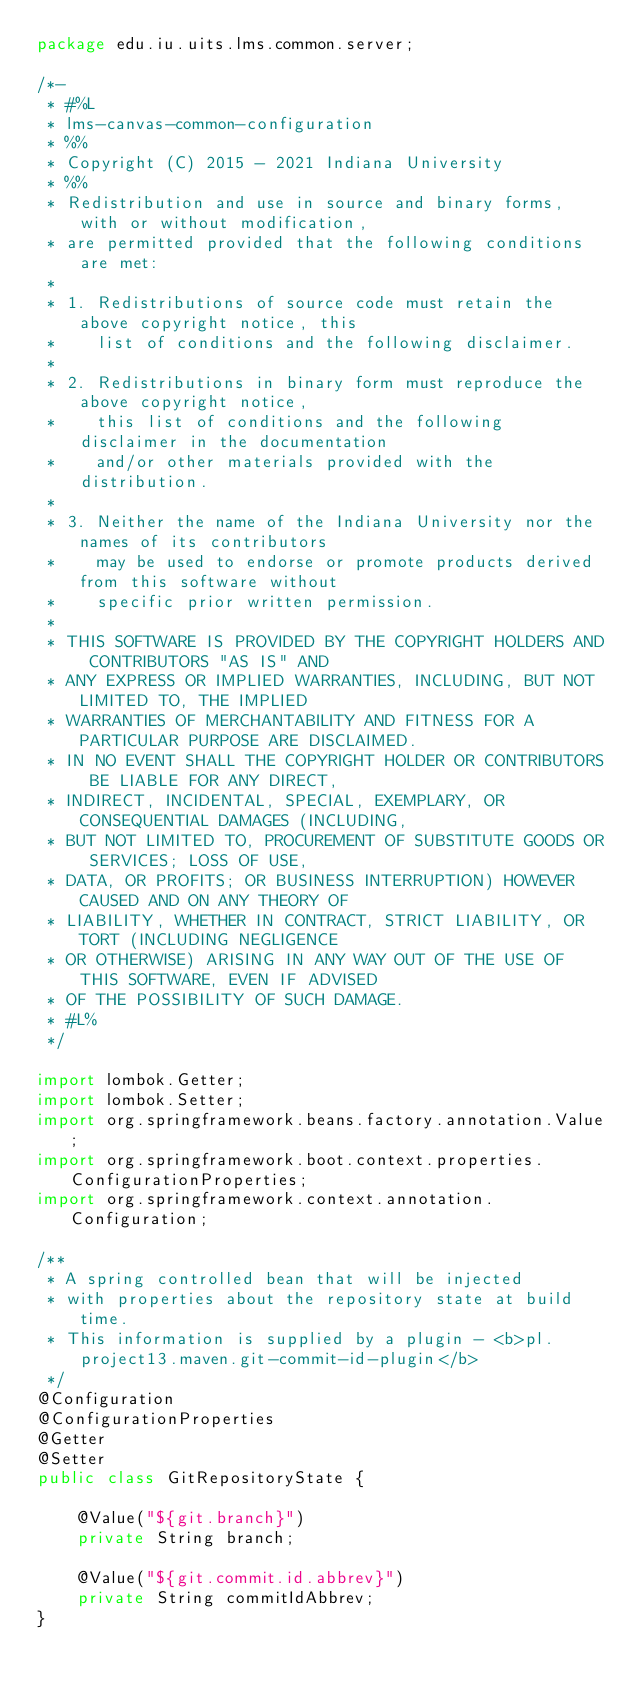Convert code to text. <code><loc_0><loc_0><loc_500><loc_500><_Java_>package edu.iu.uits.lms.common.server;

/*-
 * #%L
 * lms-canvas-common-configuration
 * %%
 * Copyright (C) 2015 - 2021 Indiana University
 * %%
 * Redistribution and use in source and binary forms, with or without modification,
 * are permitted provided that the following conditions are met:
 * 
 * 1. Redistributions of source code must retain the above copyright notice, this
 *    list of conditions and the following disclaimer.
 * 
 * 2. Redistributions in binary form must reproduce the above copyright notice,
 *    this list of conditions and the following disclaimer in the documentation
 *    and/or other materials provided with the distribution.
 * 
 * 3. Neither the name of the Indiana University nor the names of its contributors
 *    may be used to endorse or promote products derived from this software without
 *    specific prior written permission.
 * 
 * THIS SOFTWARE IS PROVIDED BY THE COPYRIGHT HOLDERS AND CONTRIBUTORS "AS IS" AND
 * ANY EXPRESS OR IMPLIED WARRANTIES, INCLUDING, BUT NOT LIMITED TO, THE IMPLIED
 * WARRANTIES OF MERCHANTABILITY AND FITNESS FOR A PARTICULAR PURPOSE ARE DISCLAIMED.
 * IN NO EVENT SHALL THE COPYRIGHT HOLDER OR CONTRIBUTORS BE LIABLE FOR ANY DIRECT,
 * INDIRECT, INCIDENTAL, SPECIAL, EXEMPLARY, OR CONSEQUENTIAL DAMAGES (INCLUDING,
 * BUT NOT LIMITED TO, PROCUREMENT OF SUBSTITUTE GOODS OR SERVICES; LOSS OF USE,
 * DATA, OR PROFITS; OR BUSINESS INTERRUPTION) HOWEVER CAUSED AND ON ANY THEORY OF
 * LIABILITY, WHETHER IN CONTRACT, STRICT LIABILITY, OR TORT (INCLUDING NEGLIGENCE
 * OR OTHERWISE) ARISING IN ANY WAY OUT OF THE USE OF THIS SOFTWARE, EVEN IF ADVISED
 * OF THE POSSIBILITY OF SUCH DAMAGE.
 * #L%
 */

import lombok.Getter;
import lombok.Setter;
import org.springframework.beans.factory.annotation.Value;
import org.springframework.boot.context.properties.ConfigurationProperties;
import org.springframework.context.annotation.Configuration;

/**
 * A spring controlled bean that will be injected
 * with properties about the repository state at build time.
 * This information is supplied by a plugin - <b>pl.project13.maven.git-commit-id-plugin</b>
 */
@Configuration
@ConfigurationProperties
@Getter
@Setter
public class GitRepositoryState {

    @Value("${git.branch}")
    private String branch;

    @Value("${git.commit.id.abbrev}")
    private String commitIdAbbrev;
}
</code> 